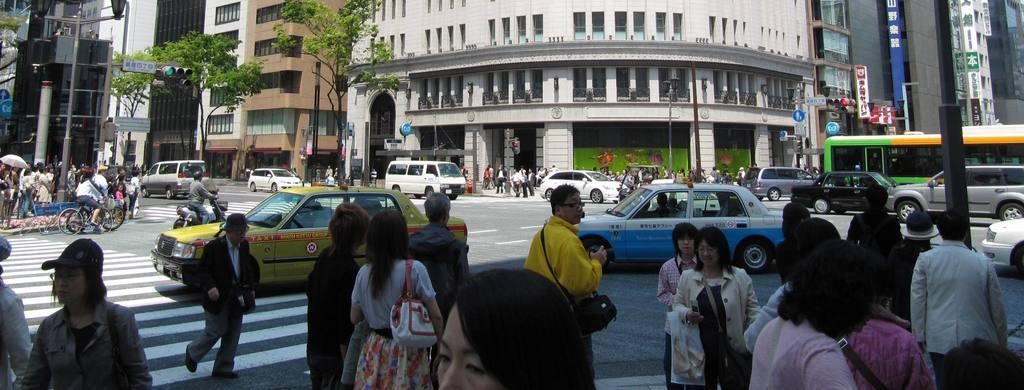What can be seen in the image involving people? There are people standing in the image. What is happening on the road in the image? There are vehicles on the road in the image. What type of natural elements are present in the image? There are trees in the image. What structures can be seen in the image? There are poles, traffic signals, and buildings in the image. Can you tell me how many clovers are growing on the trees in the image? There are no clovers present on the trees in the image; it only features trees and other elements mentioned in the facts. What type of wood is used to construct the buildings in the image? The type of wood used to construct the buildings cannot be determined from the image, as it does not provide information about the materials used in the buildings' construction. 